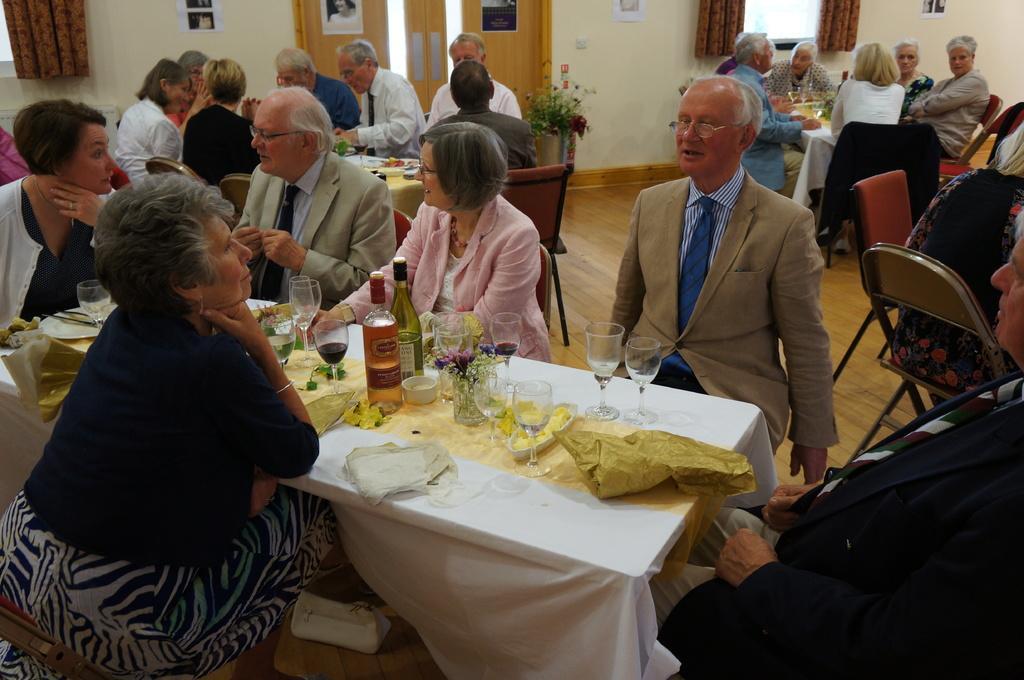Can you describe this image briefly? Here we can see groups of people sitting on chairs with table in front of them having food and glasses and bottles of wines present on it and behind them we can see at door, we can see a window and curtains present 